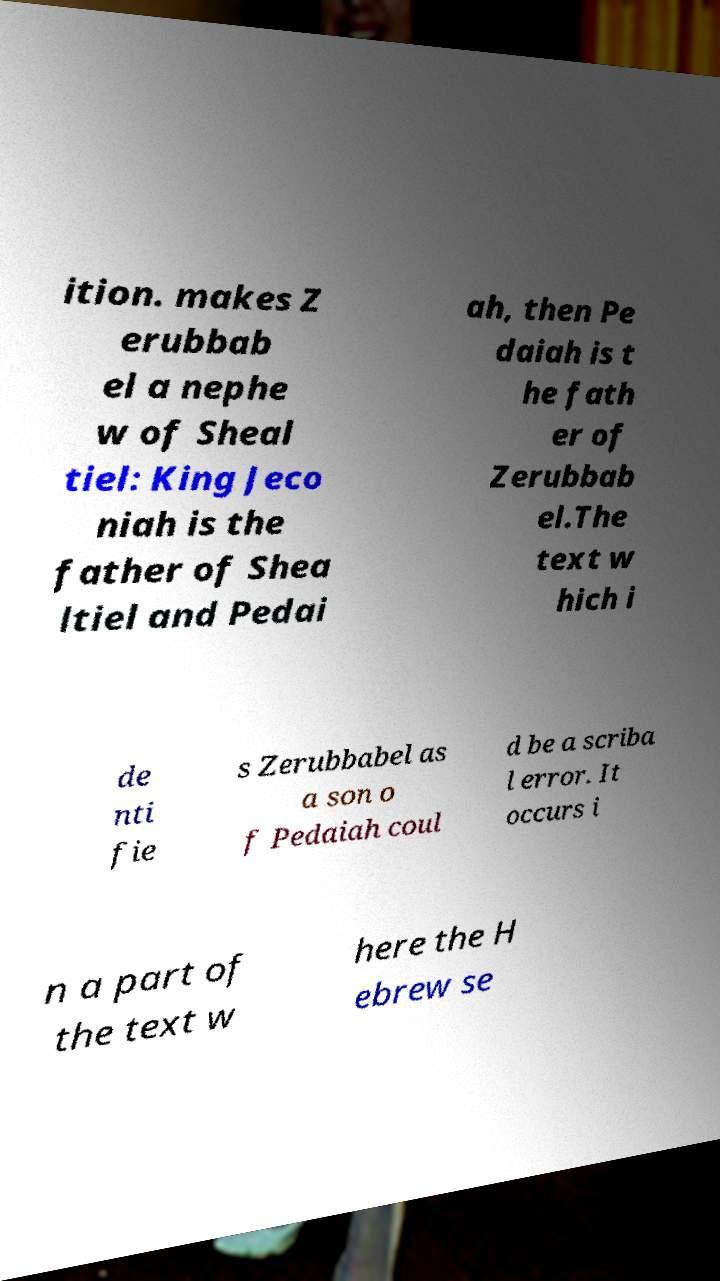Could you extract and type out the text from this image? ition. makes Z erubbab el a nephe w of Sheal tiel: King Jeco niah is the father of Shea ltiel and Pedai ah, then Pe daiah is t he fath er of Zerubbab el.The text w hich i de nti fie s Zerubbabel as a son o f Pedaiah coul d be a scriba l error. It occurs i n a part of the text w here the H ebrew se 